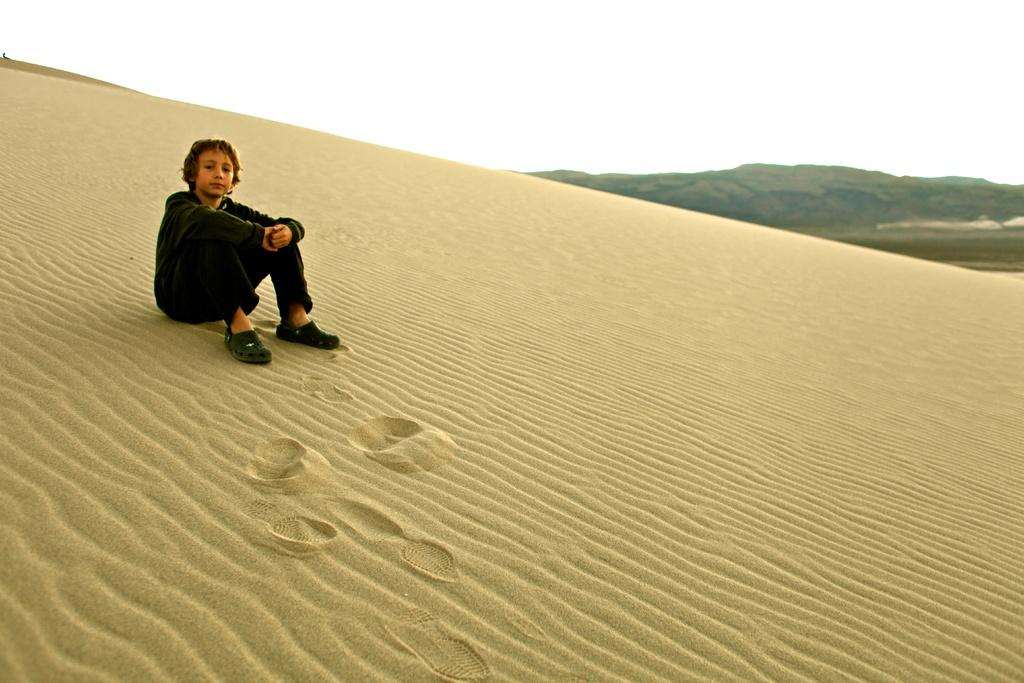What is the main subject of the image? There is a boy sitting in the image. What is at the bottom of the image? There is sand at the bottom of the image. What can be seen in the background of the image? There are mountains in the background of the image. What is visible at the top of the image? The sky is visible at the top of the image. What type of thread is being used to sew the boy's neck in the image? There is no thread or sewing present in the image; the boy is simply sitting. What color is the vein visible on the boy's arm in the image? There is no visible vein on the boy's arm in the image. 